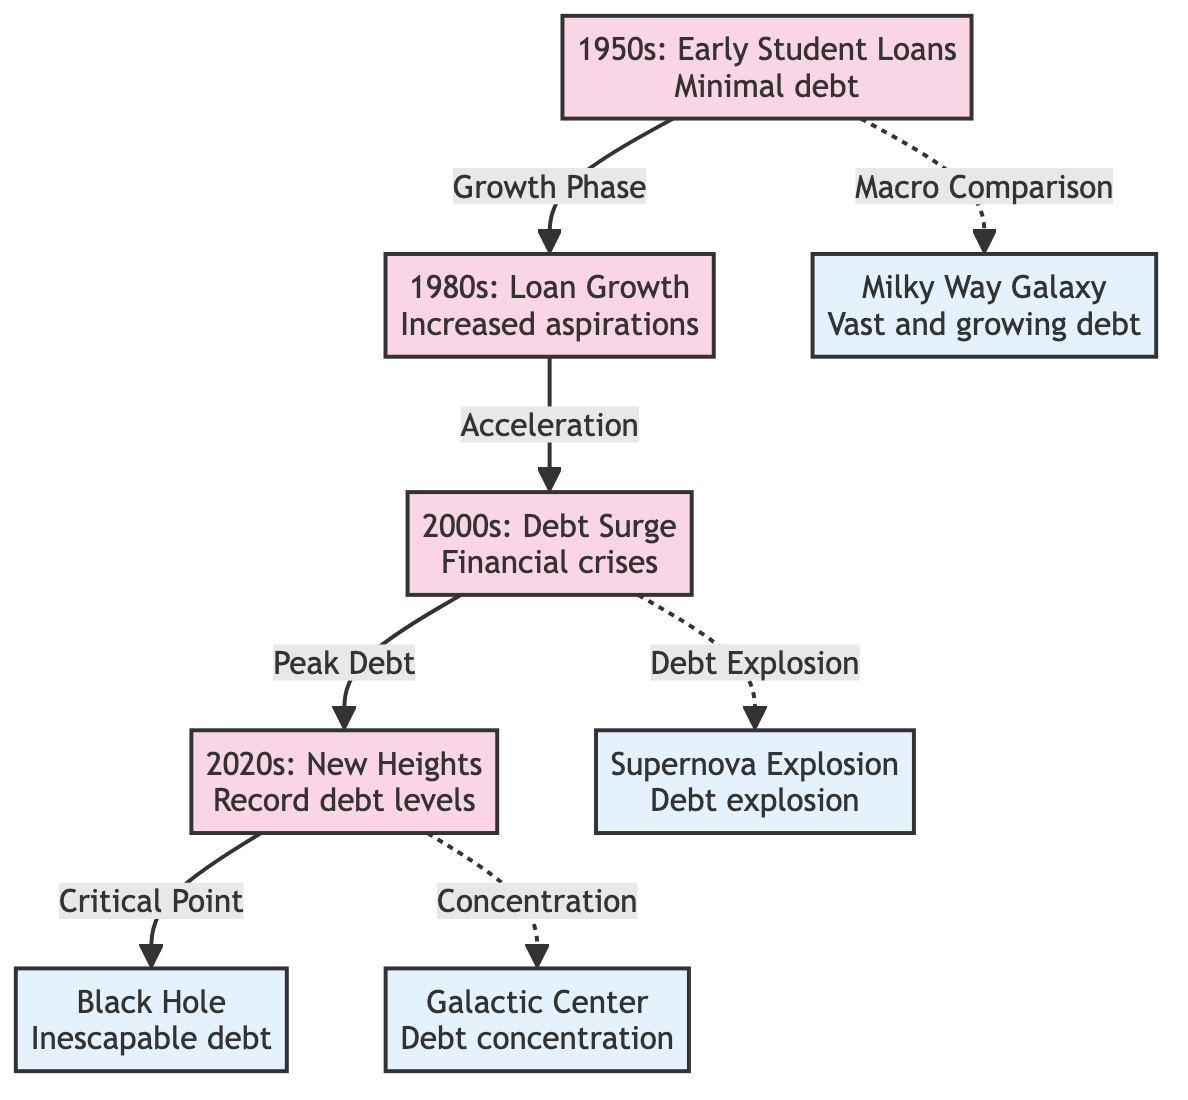What decade is associated with "Early Student Loans"? The text in the node labeled "1950s" states "1950s: Early Student Loans". Therefore, the decade associated with "Early Student Loans" is the 1950s.
Answer: 1950s What celestial event correlates with "Debt concentration"? The node labeled "Galactic Center" is specifically described as "Debt concentration". This indicates that the celestial event associated with this concept is the Galactic Center.
Answer: Galactic Center How many major eras are represented in the diagram? There are four specific nodes that represent the major eras of student loan debt: 1950s, 1980s, 2000s, and 2020s. Thus, the total count of the major eras is four.
Answer: 4 What phrase describes the transition from the 1980s to the 2000s? The diagram links the 1980s to the 2000s with the label "Acceleration". This phrase characterizes the transition between these two decades regarding student loans.
Answer: Acceleration What celestial event indicates an "Inescapable debt"? According to the diagram, the black hole is used as a metaphor for "Inescapable debt". The connection is established with the node labeled "Black Hole".
Answer: Black Hole Which era sees "Record debt levels"? The node labeled "2020s" describes the era with "Record debt levels". Hence, the era that experiences this situation is the 2020s.
Answer: 2020s What metaphorical event correlates with "Debt explosion"? The diagram provides the label "Supernova Explosion" as a metaphor for "Debt explosion". Therefore, this event correlates directly with the concept of a sudden surge in debt.
Answer: Supernova Explosion What edge connects the 2000s to the 2020s? The connection between the 2000s and the 2020s is labeled "Peak Debt". This phrase describes the relationship between these two nodes regarding the financial conditions.
Answer: Peak Debt How does the diagram illustrate the growth of student loan debt from the 1950s to the 2020s? The diagram shows a sequential flow from the 1950s to the 2020s, indicating a progression from "Minimal debt" to "Record debt levels". The arrows depict this growth over the decades.
Answer: Sequential growth Which event is depicted as reaching "Critical Point"? The connection from the 2020s leads to the "Black Hole", which is labeled as reaching a "Critical Point". Therefore, the event that reaches this state is the 2020s.
Answer: 2020s 